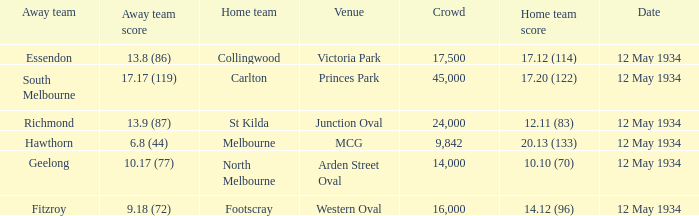Which home team played the Away team from Richmond? St Kilda. 